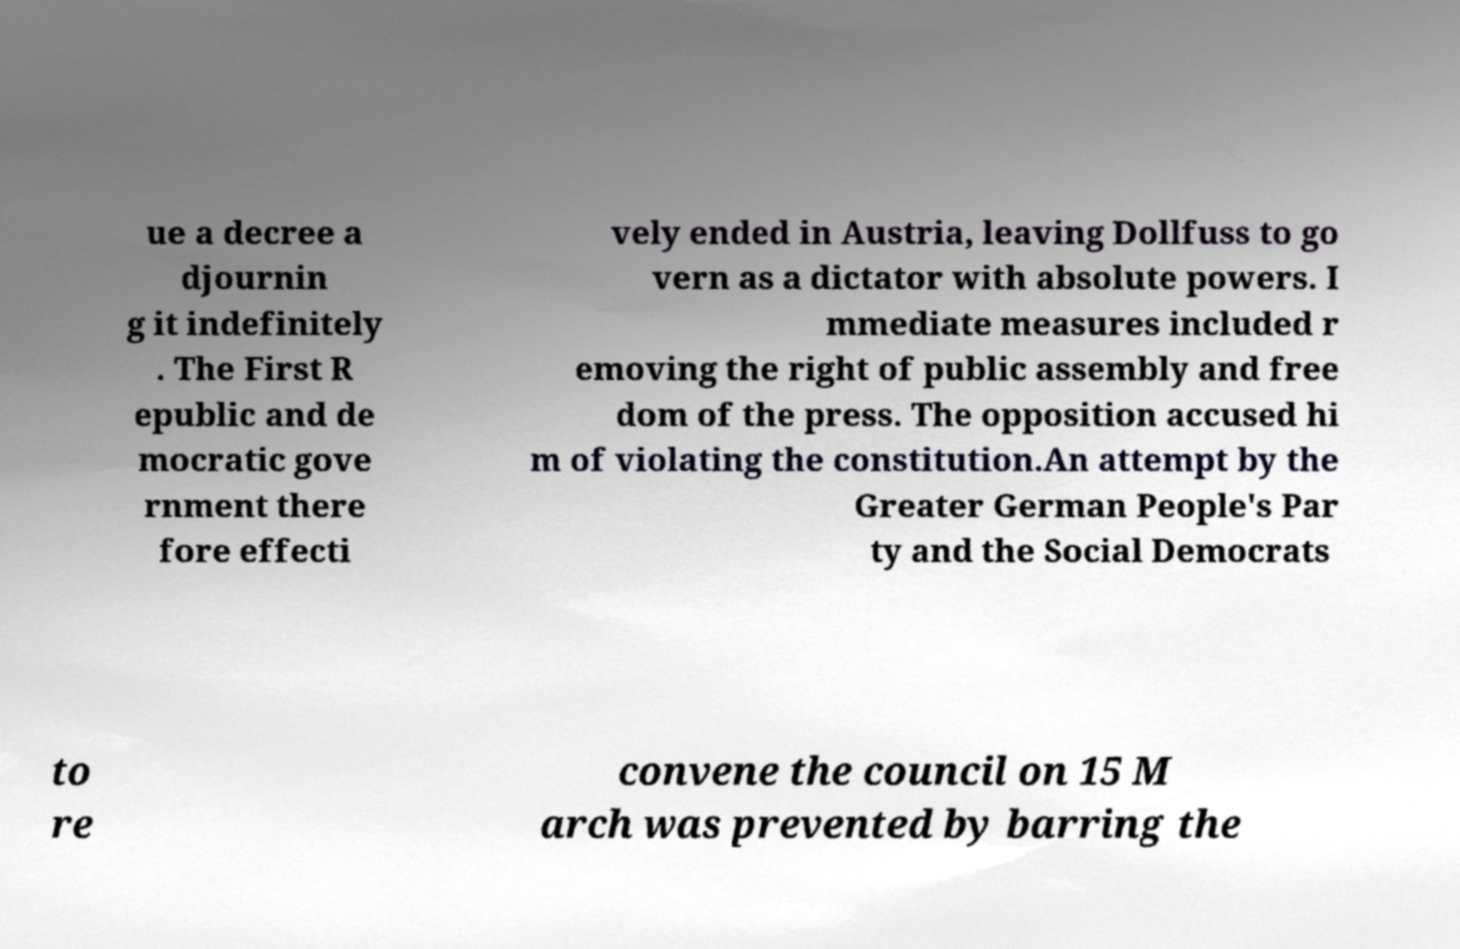For documentation purposes, I need the text within this image transcribed. Could you provide that? ue a decree a djournin g it indefinitely . The First R epublic and de mocratic gove rnment there fore effecti vely ended in Austria, leaving Dollfuss to go vern as a dictator with absolute powers. I mmediate measures included r emoving the right of public assembly and free dom of the press. The opposition accused hi m of violating the constitution.An attempt by the Greater German People's Par ty and the Social Democrats to re convene the council on 15 M arch was prevented by barring the 